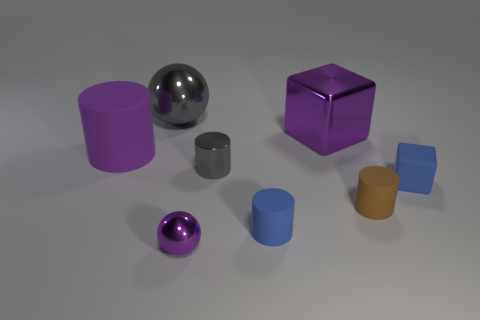What material is the tiny gray cylinder?
Ensure brevity in your answer.  Metal. The cube to the left of the small blue matte object that is on the right side of the big purple metal thing behind the small blue rubber cube is made of what material?
Provide a succinct answer. Metal. There is a purple shiny object that is the same size as the blue rubber block; what is its shape?
Offer a terse response. Sphere. What number of objects are small purple metal balls or rubber things on the right side of the small blue matte cylinder?
Give a very brief answer. 3. Do the large ball on the left side of the tiny blue matte block and the tiny brown object that is in front of the rubber block have the same material?
Keep it short and to the point. No. There is a small metallic thing that is the same color as the big matte thing; what shape is it?
Provide a succinct answer. Sphere. What number of purple things are spheres or big metal things?
Make the answer very short. 2. What size is the brown cylinder?
Your response must be concise. Small. Are there more big cylinders that are left of the brown rubber thing than red cylinders?
Your answer should be very brief. Yes. There is a small purple ball; what number of small purple things are behind it?
Offer a very short reply. 0. 